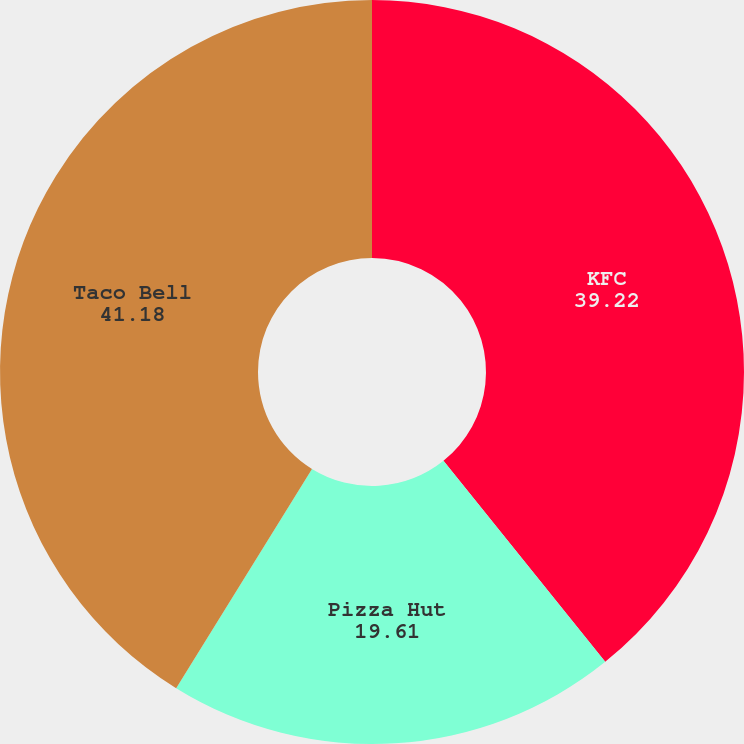Convert chart. <chart><loc_0><loc_0><loc_500><loc_500><pie_chart><fcel>KFC<fcel>Pizza Hut<fcel>Taco Bell<nl><fcel>39.22%<fcel>19.61%<fcel>41.18%<nl></chart> 